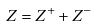<formula> <loc_0><loc_0><loc_500><loc_500>Z = Z ^ { + } + Z ^ { - }</formula> 